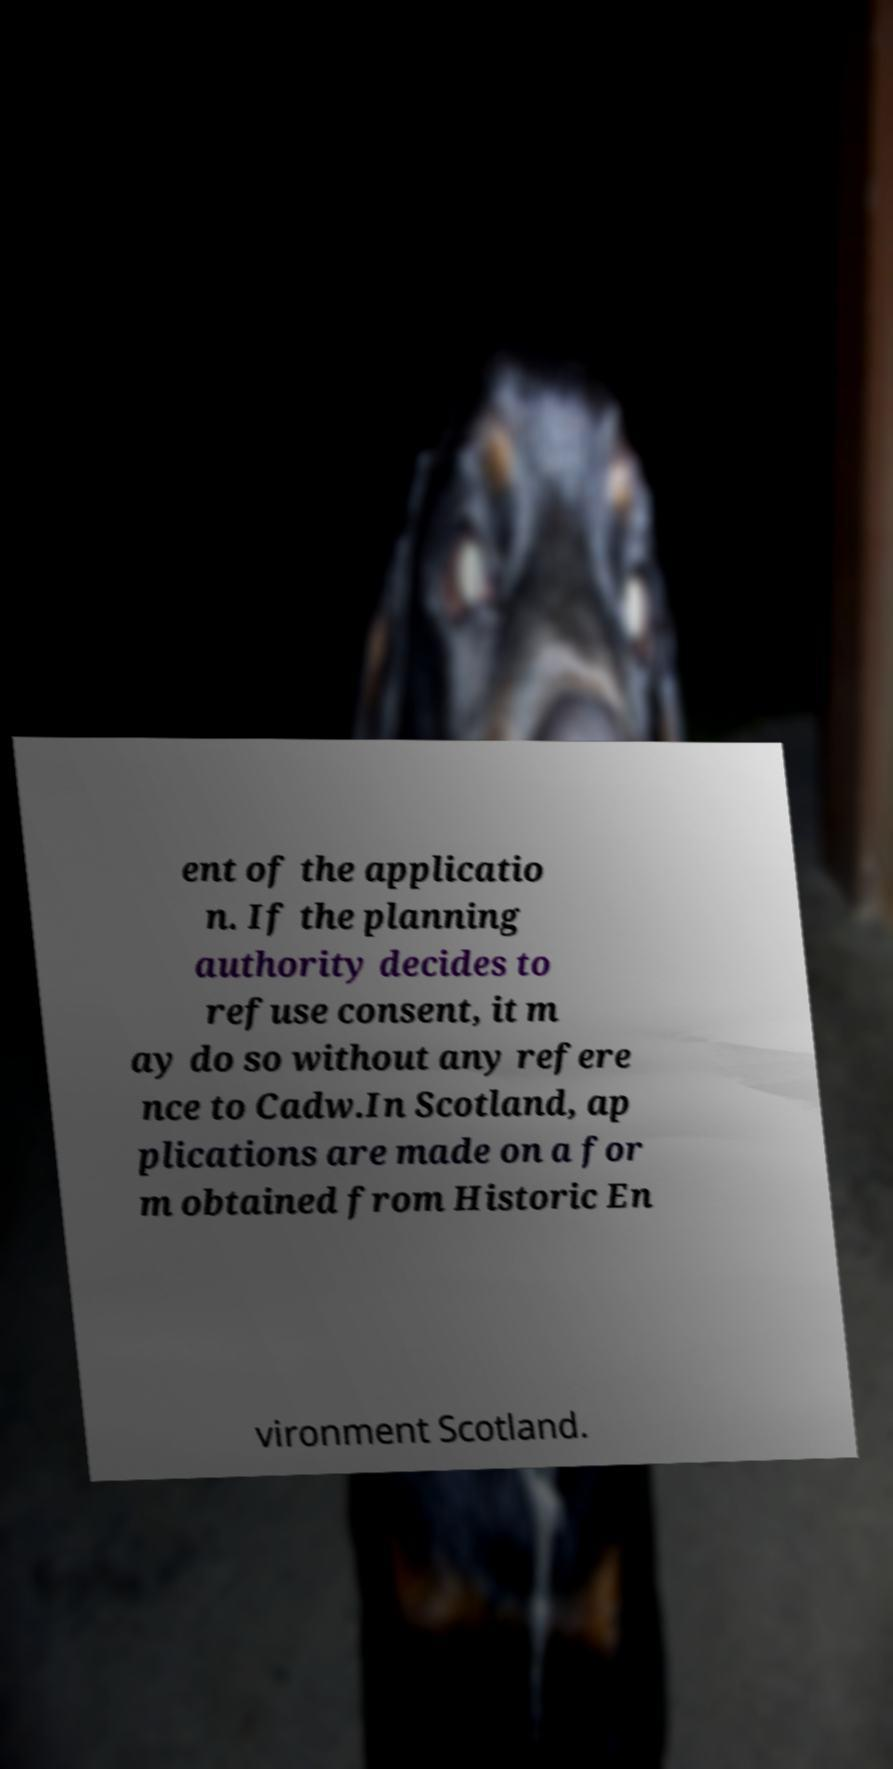I need the written content from this picture converted into text. Can you do that? ent of the applicatio n. If the planning authority decides to refuse consent, it m ay do so without any refere nce to Cadw.In Scotland, ap plications are made on a for m obtained from Historic En vironment Scotland. 